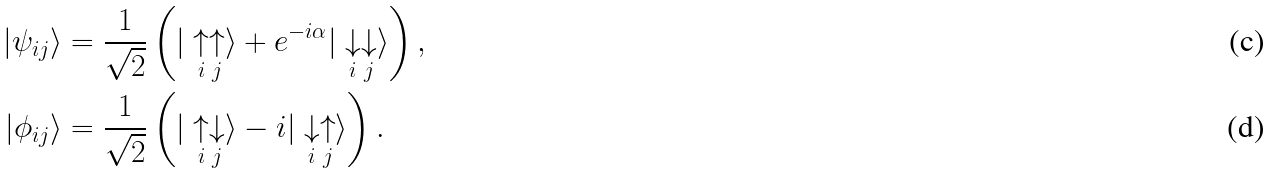Convert formula to latex. <formula><loc_0><loc_0><loc_500><loc_500>\left | \psi _ { i j } \right \rangle & = \frac { 1 } { \sqrt { 2 } } \left ( | \underset { i } { \uparrow } \underset { j } { \uparrow } \rangle + e ^ { - i \alpha } | \underset { i } { \downarrow } \underset { j } { \downarrow } \rangle \right ) , \\ \left | \phi _ { i j } \right \rangle & = \frac { 1 } { \sqrt { 2 } } \left ( | \underset { i } { \uparrow } \underset { j } { \downarrow } \rangle - i | \underset { i } { \downarrow } \underset { j } { \uparrow } \rangle \right ) .</formula> 